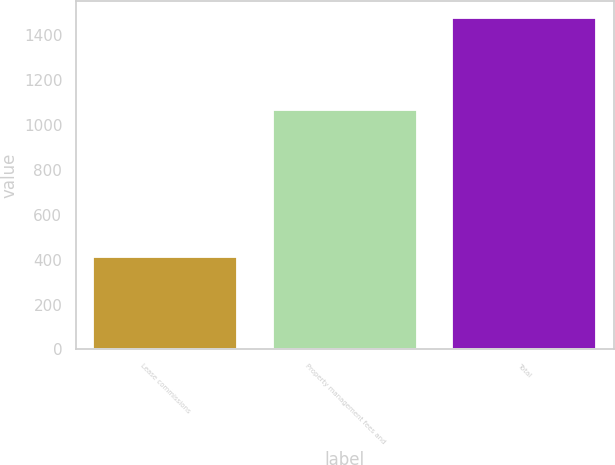Convert chart. <chart><loc_0><loc_0><loc_500><loc_500><bar_chart><fcel>Lease commissions<fcel>Property management fees and<fcel>Total<nl><fcel>411<fcel>1068<fcel>1479<nl></chart> 